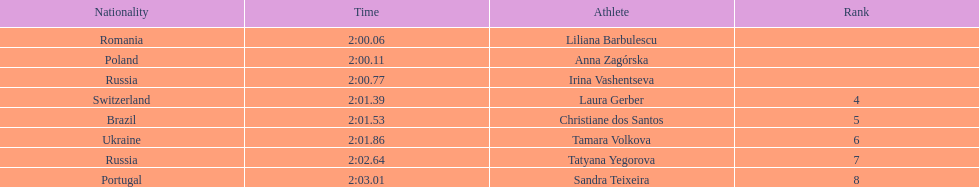The last runner crossed the finish line in 2:03.01. what was the previous time for the 7th runner? 2:02.64. 